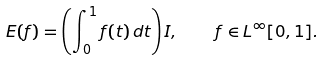Convert formula to latex. <formula><loc_0><loc_0><loc_500><loc_500>E ( f ) = \left ( \int _ { 0 } ^ { 1 } f ( t ) \, d t \right ) I , \quad f \in L ^ { \infty } [ 0 , 1 ] .</formula> 